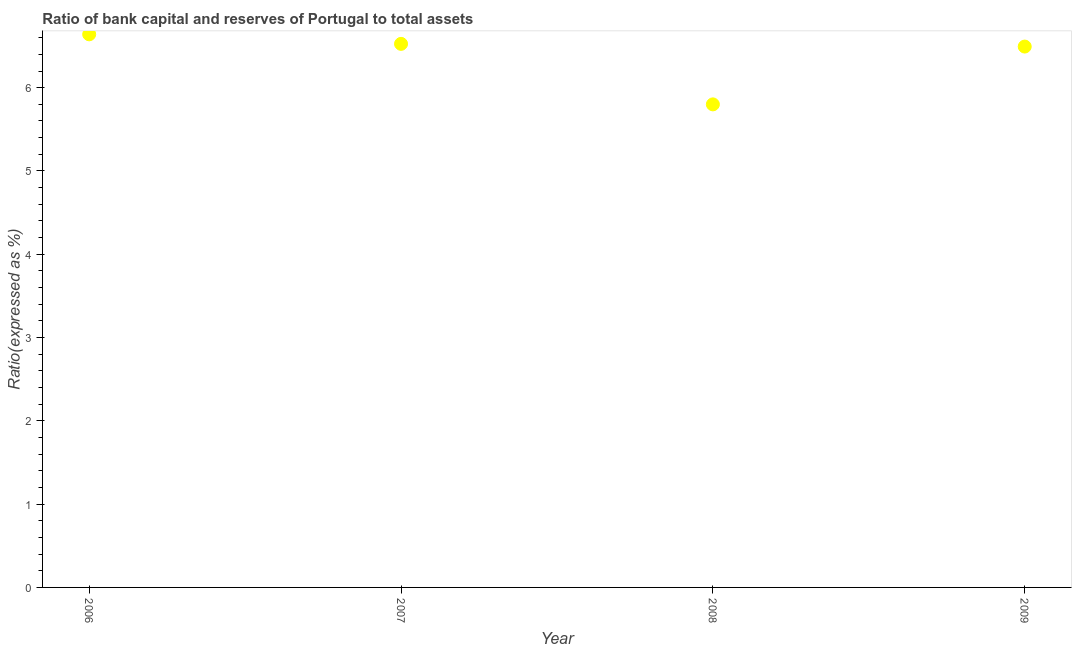What is the bank capital to assets ratio in 2007?
Make the answer very short. 6.53. Across all years, what is the maximum bank capital to assets ratio?
Give a very brief answer. 6.64. Across all years, what is the minimum bank capital to assets ratio?
Offer a very short reply. 5.8. What is the sum of the bank capital to assets ratio?
Provide a short and direct response. 25.46. What is the difference between the bank capital to assets ratio in 2006 and 2008?
Your answer should be very brief. 0.84. What is the average bank capital to assets ratio per year?
Offer a terse response. 6.36. What is the median bank capital to assets ratio?
Offer a very short reply. 6.51. In how many years, is the bank capital to assets ratio greater than 3.2 %?
Ensure brevity in your answer.  4. What is the ratio of the bank capital to assets ratio in 2007 to that in 2008?
Ensure brevity in your answer.  1.13. Is the bank capital to assets ratio in 2006 less than that in 2007?
Provide a succinct answer. No. Is the difference between the bank capital to assets ratio in 2007 and 2008 greater than the difference between any two years?
Ensure brevity in your answer.  No. What is the difference between the highest and the second highest bank capital to assets ratio?
Your response must be concise. 0.11. What is the difference between the highest and the lowest bank capital to assets ratio?
Offer a terse response. 0.84. Are the values on the major ticks of Y-axis written in scientific E-notation?
Ensure brevity in your answer.  No. Does the graph contain any zero values?
Your answer should be compact. No. What is the title of the graph?
Your answer should be compact. Ratio of bank capital and reserves of Portugal to total assets. What is the label or title of the Y-axis?
Your response must be concise. Ratio(expressed as %). What is the Ratio(expressed as %) in 2006?
Ensure brevity in your answer.  6.64. What is the Ratio(expressed as %) in 2007?
Ensure brevity in your answer.  6.53. What is the Ratio(expressed as %) in 2008?
Offer a terse response. 5.8. What is the Ratio(expressed as %) in 2009?
Your answer should be very brief. 6.49. What is the difference between the Ratio(expressed as %) in 2006 and 2007?
Your response must be concise. 0.11. What is the difference between the Ratio(expressed as %) in 2006 and 2008?
Make the answer very short. 0.84. What is the difference between the Ratio(expressed as %) in 2006 and 2009?
Your response must be concise. 0.15. What is the difference between the Ratio(expressed as %) in 2007 and 2008?
Offer a very short reply. 0.73. What is the difference between the Ratio(expressed as %) in 2007 and 2009?
Ensure brevity in your answer.  0.03. What is the difference between the Ratio(expressed as %) in 2008 and 2009?
Ensure brevity in your answer.  -0.69. What is the ratio of the Ratio(expressed as %) in 2006 to that in 2007?
Provide a short and direct response. 1.02. What is the ratio of the Ratio(expressed as %) in 2006 to that in 2008?
Offer a very short reply. 1.15. What is the ratio of the Ratio(expressed as %) in 2008 to that in 2009?
Your answer should be compact. 0.89. 